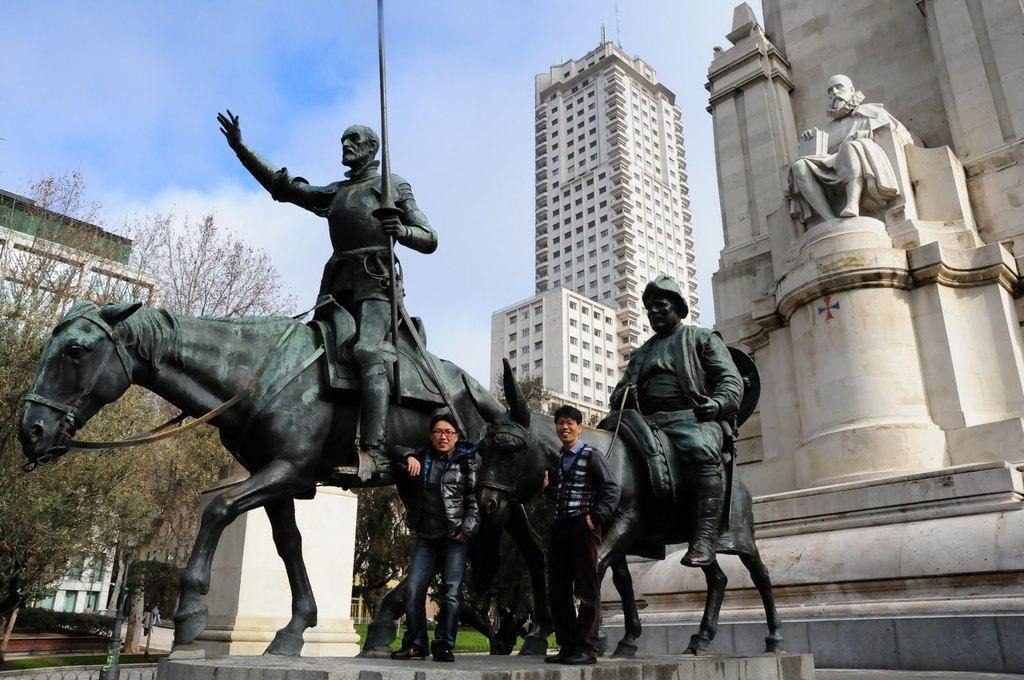How would you summarize this image in a sentence or two? In this image there are statues, near the statues there are two persons standing, in the background there are trees, buildings and the sky. 